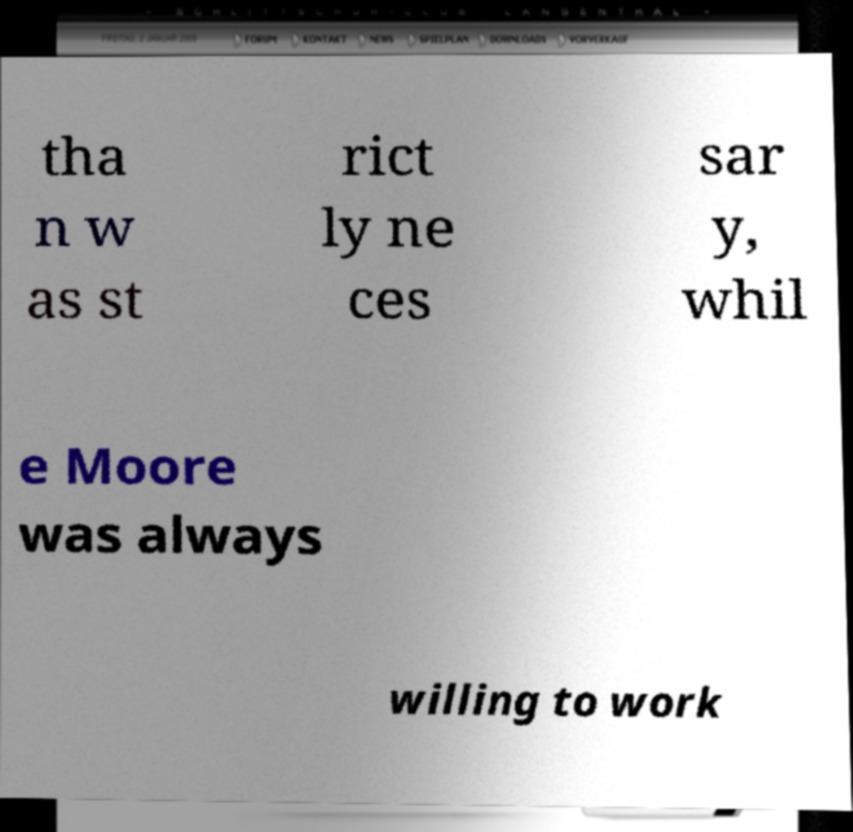Can you read and provide the text displayed in the image?This photo seems to have some interesting text. Can you extract and type it out for me? tha n w as st rict ly ne ces sar y, whil e Moore was always willing to work 